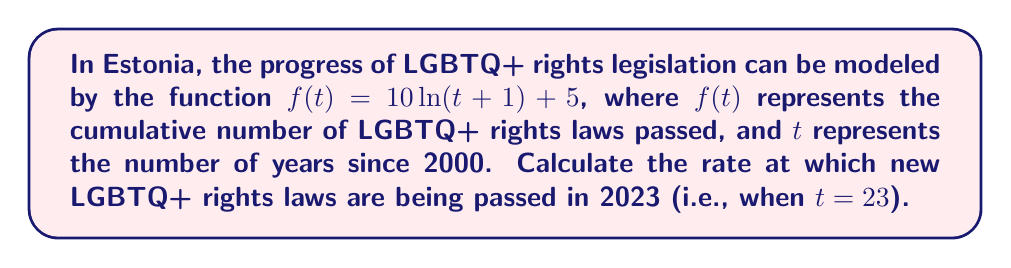Could you help me with this problem? To solve this problem, we need to find the derivative of the given function and then evaluate it at $t=23$. Here's the step-by-step process:

1) The given function is $f(t) = 10\ln(t+1) + 5$

2) To find the rate of change, we need to calculate $f'(t)$:
   $$f'(t) = \frac{d}{dt}[10\ln(t+1) + 5]$$

3) Using the chain rule and the fact that the derivative of a constant is zero:
   $$f'(t) = 10 \cdot \frac{d}{dt}[\ln(t+1)] + 0$$

4) The derivative of $\ln(x)$ is $\frac{1}{x}$, so:
   $$f'(t) = 10 \cdot \frac{1}{t+1}$$

5) Simplifying:
   $$f'(t) = \frac{10}{t+1}$$

6) Now, we need to evaluate $f'(23)$:
   $$f'(23) = \frac{10}{23+1} = \frac{10}{24} = \frac{5}{12} \approx 0.4167$$

This result represents the instantaneous rate of change in the number of LGBTQ+ rights laws being passed in 2023.
Answer: The rate at which new LGBTQ+ rights laws are being passed in Estonia in 2023 is $\frac{5}{12}$ laws per year, or approximately 0.4167 laws per year. 